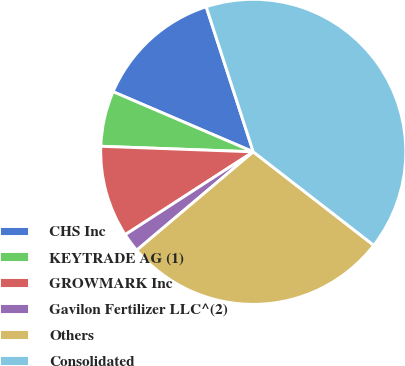Convert chart to OTSL. <chart><loc_0><loc_0><loc_500><loc_500><pie_chart><fcel>CHS Inc<fcel>KEYTRADE AG (1)<fcel>GROWMARK Inc<fcel>Gavilon Fertilizer LLC^(2)<fcel>Others<fcel>Consolidated<nl><fcel>13.56%<fcel>5.87%<fcel>9.72%<fcel>2.02%<fcel>28.34%<fcel>40.49%<nl></chart> 